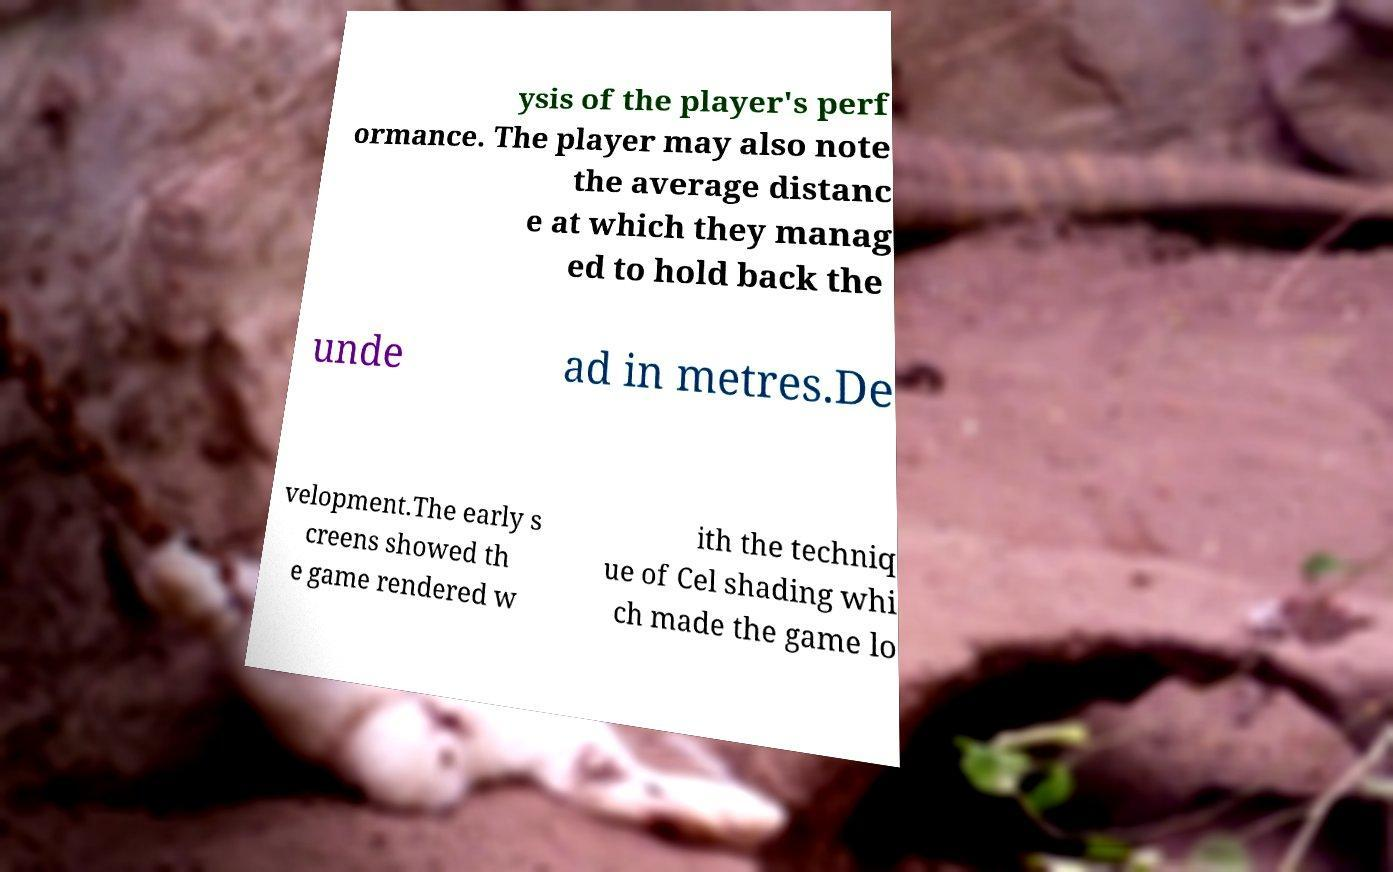There's text embedded in this image that I need extracted. Can you transcribe it verbatim? ysis of the player's perf ormance. The player may also note the average distanc e at which they manag ed to hold back the unde ad in metres.De velopment.The early s creens showed th e game rendered w ith the techniq ue of Cel shading whi ch made the game lo 